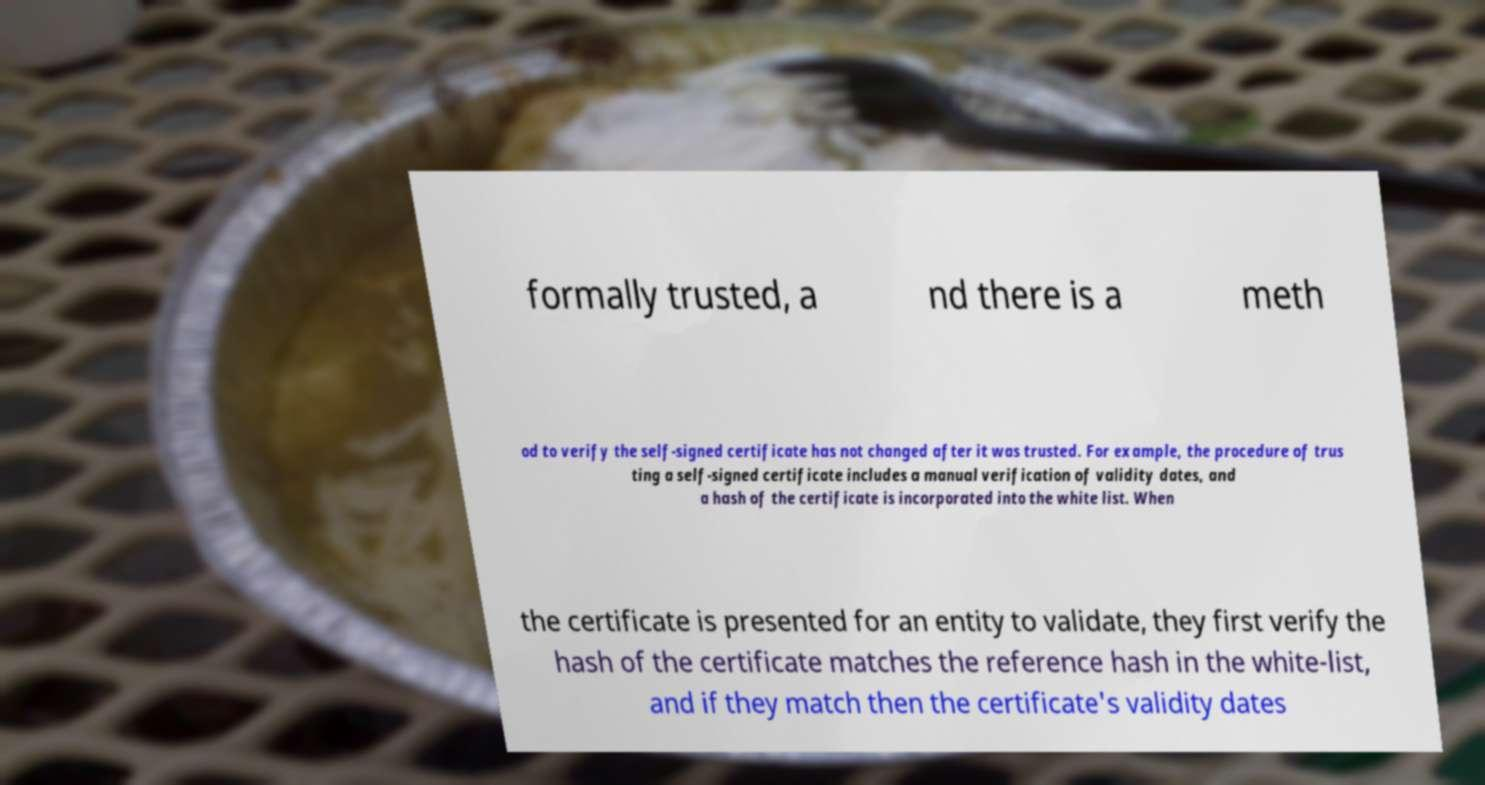There's text embedded in this image that I need extracted. Can you transcribe it verbatim? formally trusted, a nd there is a meth od to verify the self-signed certificate has not changed after it was trusted. For example, the procedure of trus ting a self-signed certificate includes a manual verification of validity dates, and a hash of the certificate is incorporated into the white list. When the certificate is presented for an entity to validate, they first verify the hash of the certificate matches the reference hash in the white-list, and if they match then the certificate's validity dates 